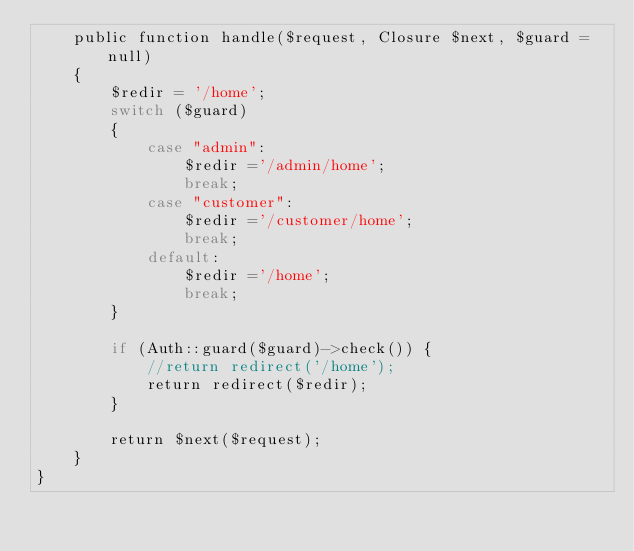Convert code to text. <code><loc_0><loc_0><loc_500><loc_500><_PHP_>    public function handle($request, Closure $next, $guard = null)
    {
        $redir = '/home';
        switch ($guard)
        {
            case "admin":
                $redir ='/admin/home';
                break;
            case "customer":
                $redir ='/customer/home';
                break;
            default:
                $redir ='/home';
                break;
        }

        if (Auth::guard($guard)->check()) {
            //return redirect('/home');
            return redirect($redir);
        }

        return $next($request);
    }
}
</code> 